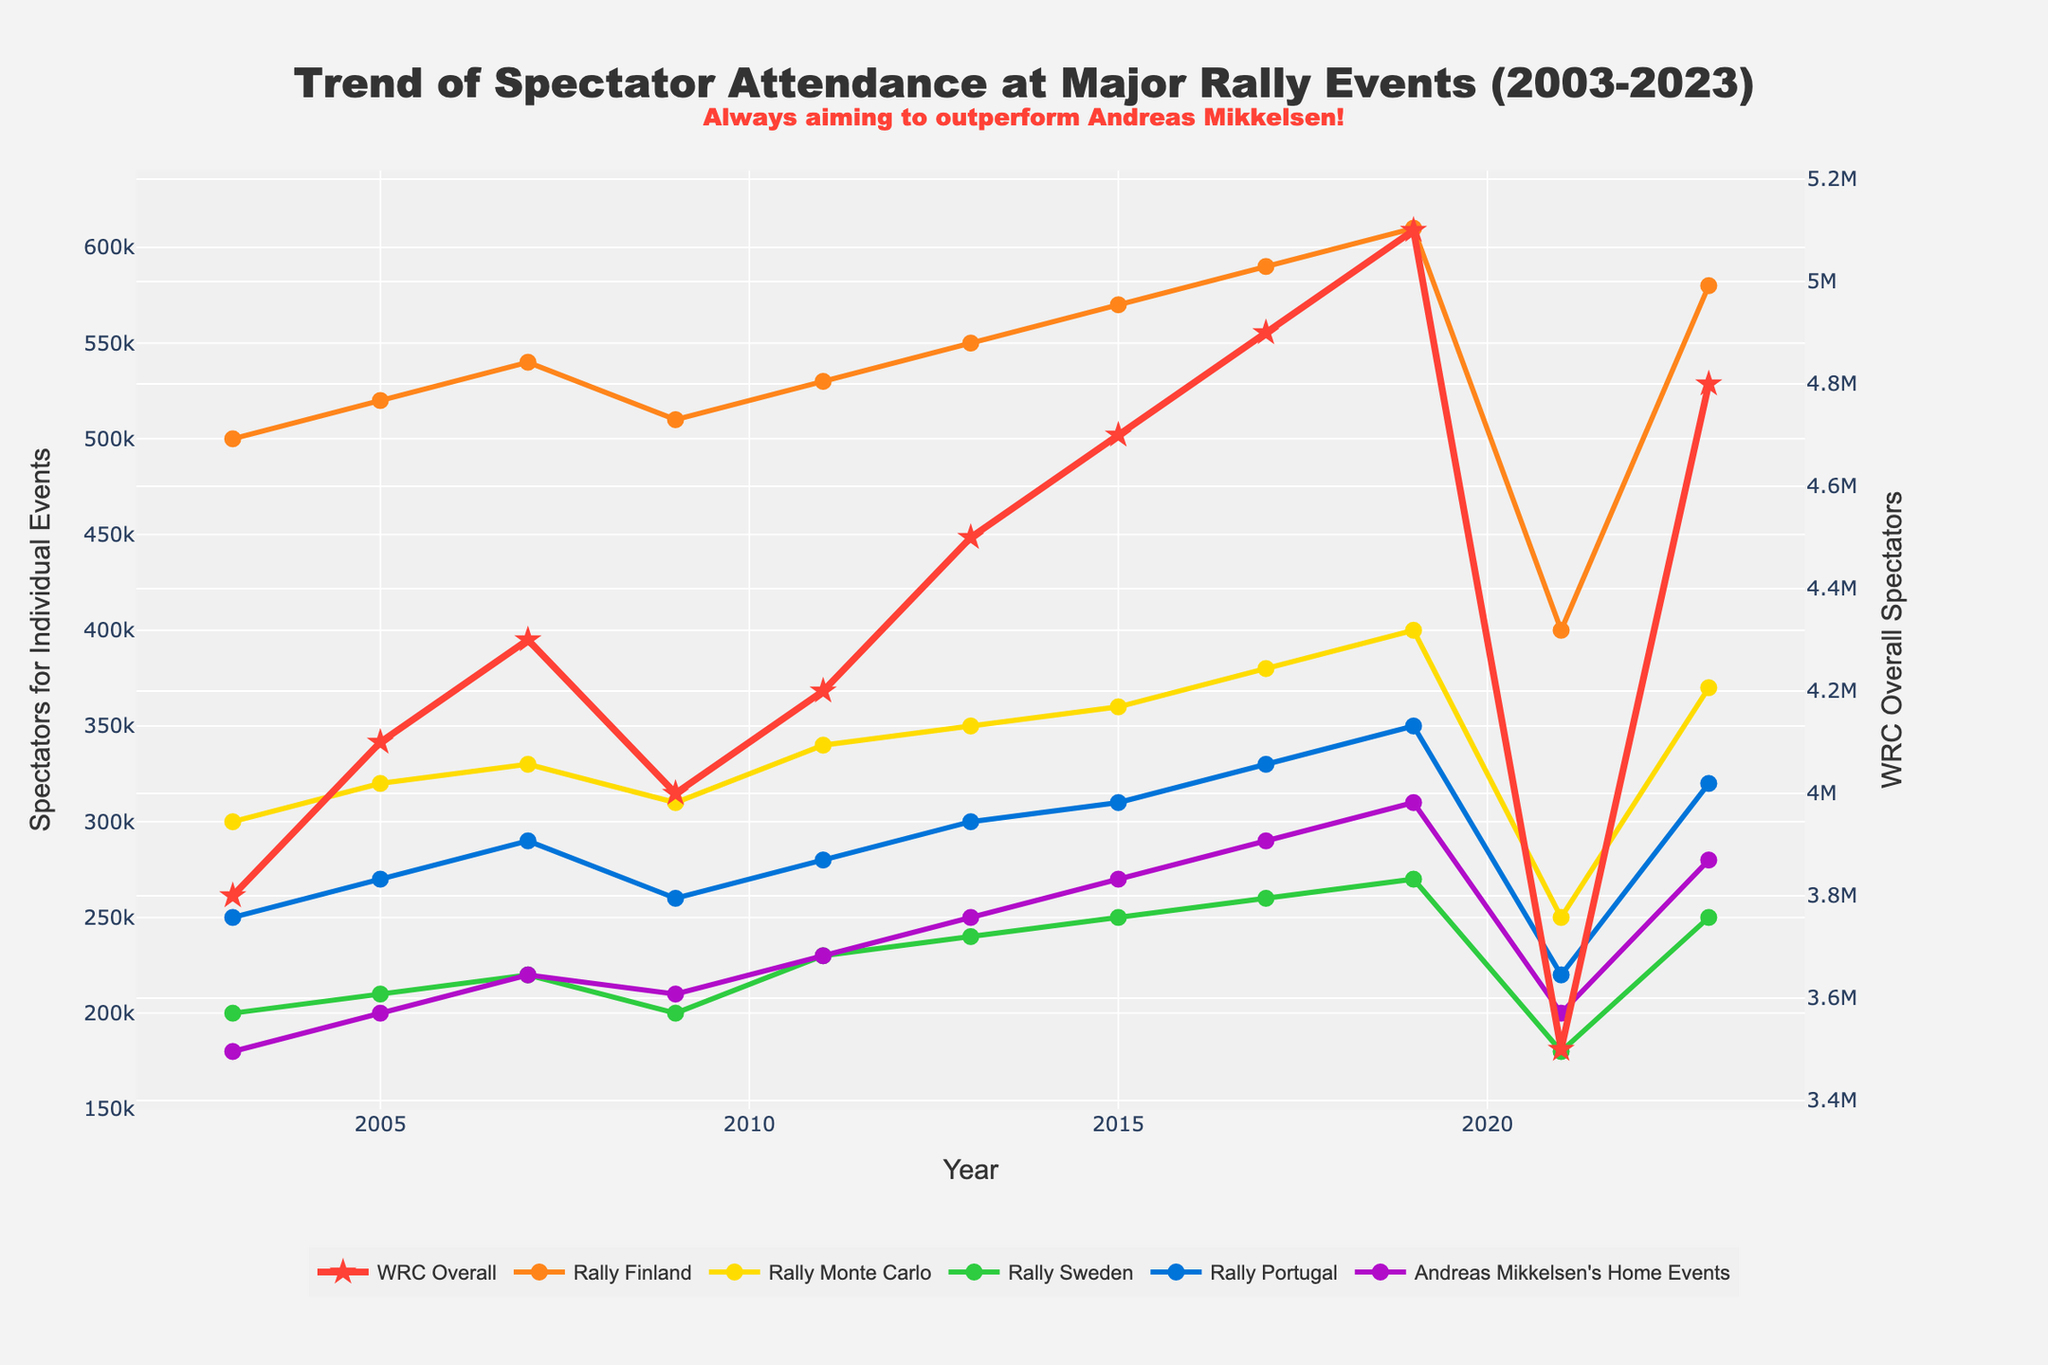What was the overall trend of WRC spectators from 2003 to 2023? To determine the overall trend, observe the line representing 'WRC Overall' from 2003 to 2023 on the secondary y-axis. The trend shows an initial increase from 2003 to 2019, followed by a significant drop in 2021, and then a recovery in 2023.
Answer: Increasing, then decreasing, followed by recovery Which rally event had the highest attendance in 2023? To find the event with the highest attendance in 2023, locate the end points of each colored line on the primary y-axis. 'Rally Finland' in blue had the highest attendance in 2023.
Answer: Rally Finland How did Andreas Mikkelsen's home event spectators change from 2005 to 2015? Look at the line representing "Andreas Mikkelsen's Home Events" on the primary y-axis. Compare the value in 2005 and the value in 2015. The spectators increased from 200,000 in 2005 to 270,000 in 2015.
Answer: Increased by 70,000 By how much did WRC Overall spectators decrease from 2019 to 2021? Compare the y-values for 'WRC Overall' on the secondary y-axis for the years 2019 and 2021. In 2019, it was 5,100,000, and in 2021, it was 3,500,000. The decrease is 5,100,000 - 3,500,000 = 1,600,000.
Answer: Decreased by 1,600,000 Which rally event showed the most consistent spectator trend from 2003 to 2023? To find the most consistent trend, look for the line with the least variation on the primary y-axis. 'Rally Monte Carlo' demonstrated a relatively steady increase without drastic fluctuations.
Answer: Rally Monte Carlo Compare the spectator attendance for Rally Portugal in 2005 and 2023. Locate the point for 'Rally Portugal' on the primary y-axis for the years 2005 and 2023. In 2005, it was 270,000, and in 2023, it was 320,000.
Answer: Increased by 50,000 What is the average spectator attendance for Rally Sweden from 2003 to 2023? To find the average, sum the spectator values for 'Rally Sweden' from 2003 to 2023: (200,000 + 210,000 + 220,000 + 200,000 + 230,000 + 240,000 + 250,000 + 260,000 + 270,000 + 180,000 + 250,000) = 2510,000, and divide by 11 (number of years). 2510,000 / 11 = 228,182.
Answer: 228,182 Which two rally events show the largest difference in spectator numbers in 2011? Check the points for all rally events in 2011. 'Rally Finland' had 530,000, and 'Andreas Mikkelsen's Home Events' had 230,000. The difference is 530,000 - 230,000 = 300,000.
Answer: Rally Finland and Andreas Mikkelsen's Home Events Between 2005 and 2007, which rally event increased by the smallest amount in spectator numbers? Compare the spectator numbers for all rally events between 2005 and 2007. 'Rally Finland' increased from 520,000 to 540,000, and all other events had larger increases.
Answer: Rally Finland 